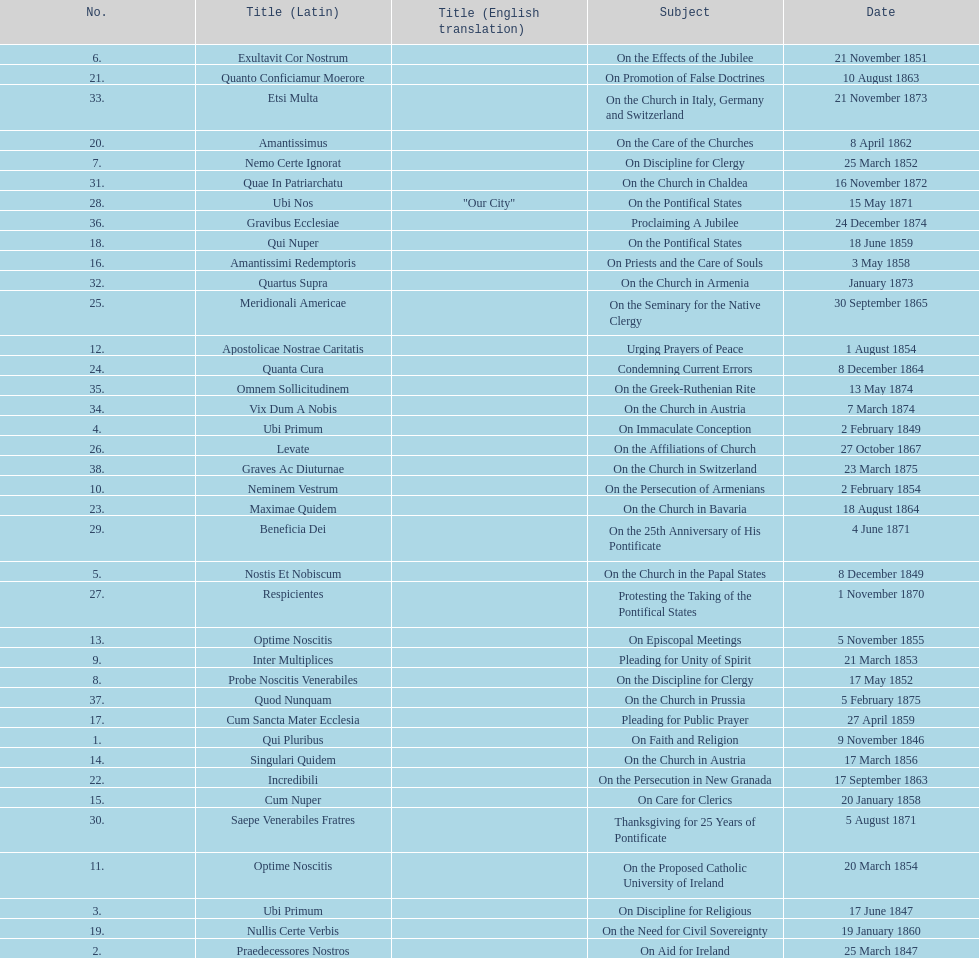What was the topic discussed prior to the effects of the jubilee? On the Church in the Papal States. 